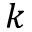Convert formula to latex. <formula><loc_0><loc_0><loc_500><loc_500>k</formula> 